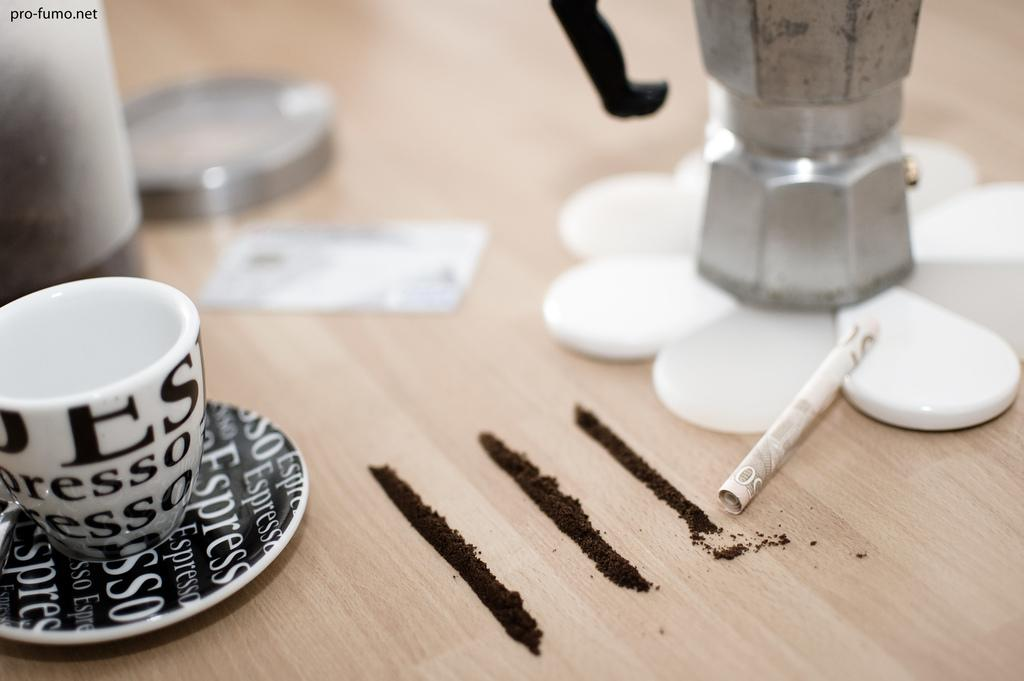What is present on the table in the image? There is a cup, a saucer, a paper, and powder on the table in the image. What is the cup resting on? The cup is resting on a saucer. What can be seen on the paper in the image? The facts provided do not give information about the paper's content. What is the nature of the powder on the table? The facts provided do not specify the type of powder on the table. What is visible at the top of the image? There is some text visible at the top of the image. What type of leather is being used to make the potato in the image? There is no potato or leather present in the image. Who is the expert in the image? There is no expert or reference to expertise in the image. 